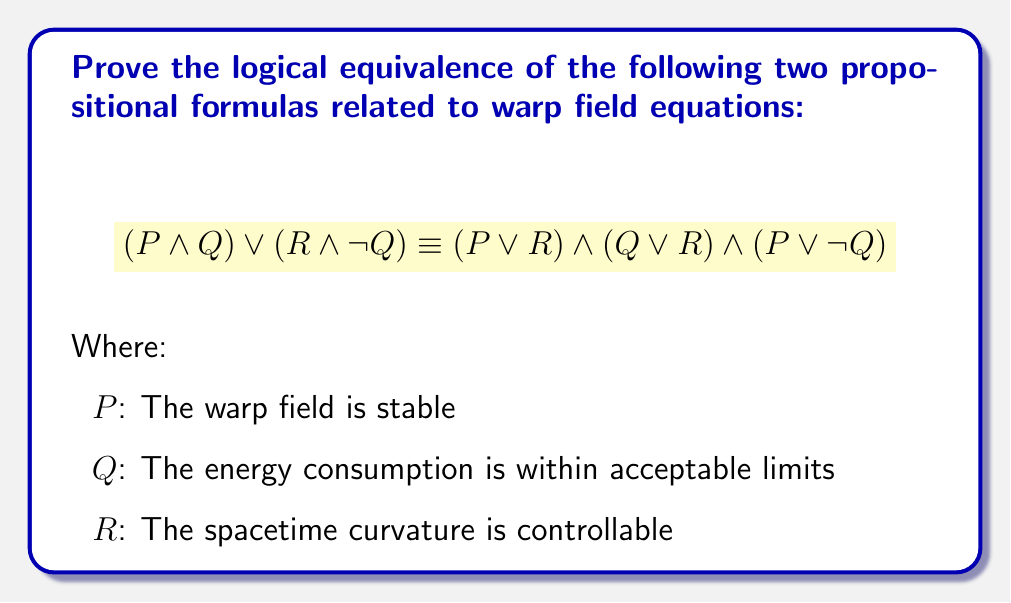Could you help me with this problem? To prove the logical equivalence of these two formulas, we'll use a step-by-step approach using logical equivalences and laws of propositional logic:

1. Start with the left-hand side (LHS): $(P \land Q) \lor (R \land \neg Q)$

2. Apply the distributive law to the right-hand side (RHS):
   $$(P \lor R) \land (Q \lor R) \land (P \lor \neg Q)$$
   
3. Expand the LHS using the distributive law:
   $$(P \land Q) \lor (R \land \neg Q) \equiv (P \lor R) \land (P \lor \neg Q) \land (Q \lor R) \land (\neg Q \lor R)$$

4. The terms $(P \lor R)$ and $(Q \lor R)$ are already present in the RHS.

5. We need to show that $(\neg Q \lor R)$ is redundant. To do this, we can use the absorption law:
   $$(Q \lor R) \land (\neg Q \lor R) \equiv (Q \lor R)$$

   This is because:
   - If $Q$ is true, $(Q \lor R)$ is true regardless of $R$.
   - If $Q$ is false, $\neg Q$ is true, so $(\neg Q \lor R)$ is true regardless of $R$.

6. Therefore, the LHS simplifies to:
   $$(P \lor R) \land (P \lor \neg Q) \land (Q \lor R)$$

7. This is identical to the RHS, proving the logical equivalence.

From a warp drive engineering perspective, this equivalence shows that the conditions for a viable warp field can be expressed in two logically equivalent ways:
- Either the field is stable with acceptable energy consumption, or the spacetime curvature is controllable but energy consumption is high.
- This is equivalent to saying that either the field is stable or the curvature is controllable, and either the energy consumption is acceptable or the curvature is controllable, and either the field is stable or the energy consumption is high.
Answer: The two propositional formulas are logically equivalent:

$$(P \land Q) \lor (R \land \neg Q) \equiv (P \lor R) \land (Q \lor R) \land (P \lor \neg Q)$$ 